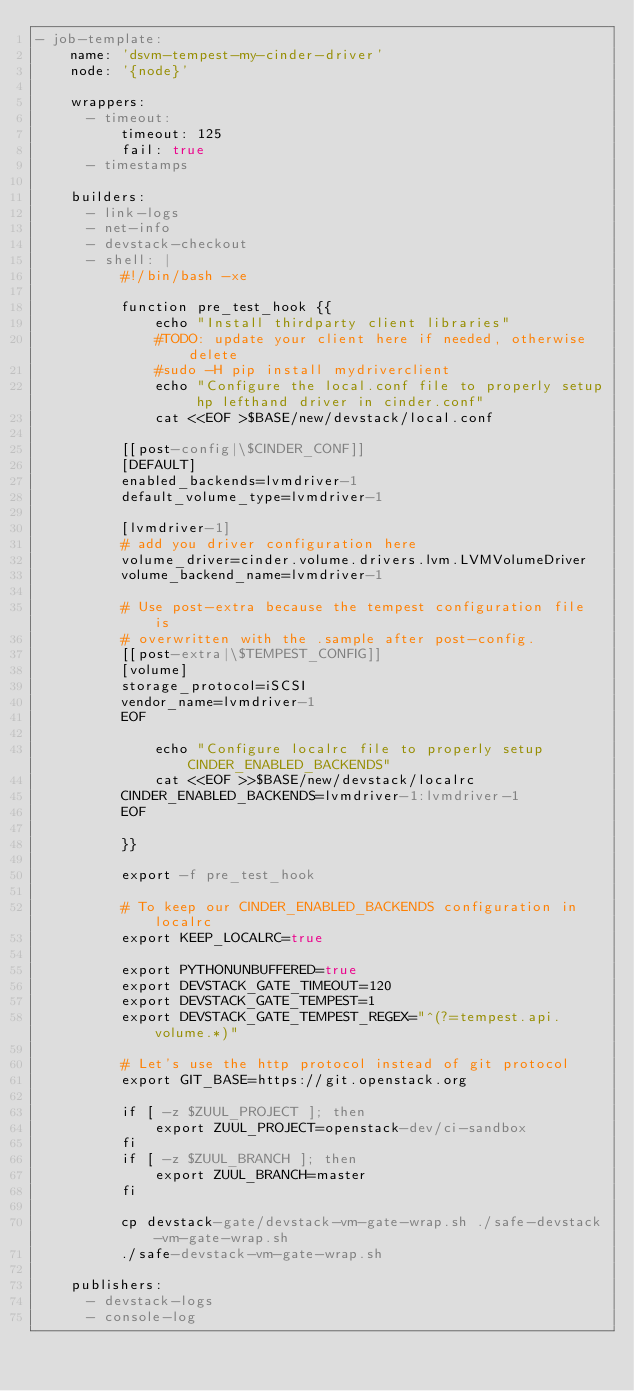<code> <loc_0><loc_0><loc_500><loc_500><_YAML_>- job-template:
    name: 'dsvm-tempest-my-cinder-driver'
    node: '{node}'

    wrappers:
      - timeout:
          timeout: 125
          fail: true
      - timestamps

    builders:
      - link-logs
      - net-info
      - devstack-checkout
      - shell: |
          #!/bin/bash -xe

          function pre_test_hook {{
              echo "Install thirdparty client libraries"
              #TODO: update your client here if needed, otherwise delete
              #sudo -H pip install mydriverclient
              echo "Configure the local.conf file to properly setup hp lefthand driver in cinder.conf"
              cat <<EOF >$BASE/new/devstack/local.conf

          [[post-config|\$CINDER_CONF]]
          [DEFAULT]
          enabled_backends=lvmdriver-1
          default_volume_type=lvmdriver-1

          [lvmdriver-1]
          # add you driver configuration here
          volume_driver=cinder.volume.drivers.lvm.LVMVolumeDriver
          volume_backend_name=lvmdriver-1

          # Use post-extra because the tempest configuration file is
          # overwritten with the .sample after post-config.
          [[post-extra|\$TEMPEST_CONFIG]]
          [volume]
          storage_protocol=iSCSI
          vendor_name=lvmdriver-1
          EOF

              echo "Configure localrc file to properly setup CINDER_ENABLED_BACKENDS"
              cat <<EOF >>$BASE/new/devstack/localrc
          CINDER_ENABLED_BACKENDS=lvmdriver-1:lvmdriver-1
          EOF

          }}

          export -f pre_test_hook

          # To keep our CINDER_ENABLED_BACKENDS configuration in localrc
          export KEEP_LOCALRC=true

          export PYTHONUNBUFFERED=true
          export DEVSTACK_GATE_TIMEOUT=120
          export DEVSTACK_GATE_TEMPEST=1
          export DEVSTACK_GATE_TEMPEST_REGEX="^(?=tempest.api.volume.*)"

          # Let's use the http protocol instead of git protocol
          export GIT_BASE=https://git.openstack.org

          if [ -z $ZUUL_PROJECT ]; then
              export ZUUL_PROJECT=openstack-dev/ci-sandbox
          fi
          if [ -z $ZUUL_BRANCH ]; then
              export ZUUL_BRANCH=master
          fi

          cp devstack-gate/devstack-vm-gate-wrap.sh ./safe-devstack-vm-gate-wrap.sh
          ./safe-devstack-vm-gate-wrap.sh

    publishers:
      - devstack-logs
      - console-log
</code> 